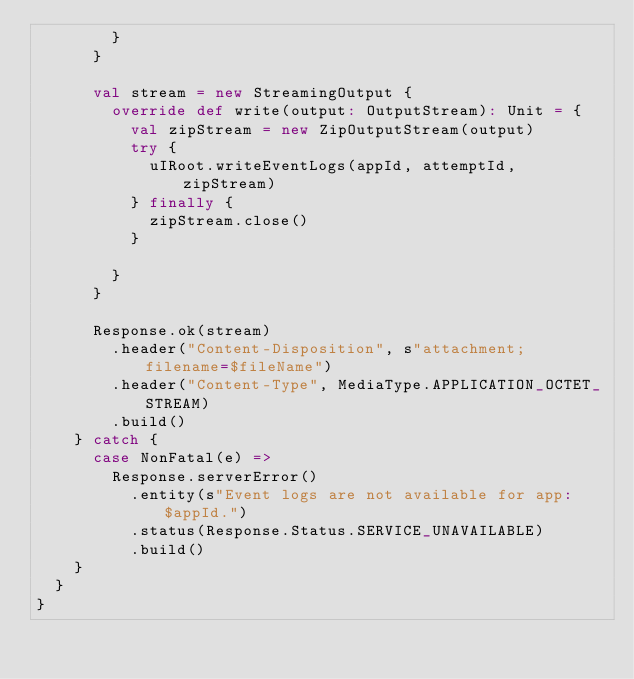Convert code to text. <code><loc_0><loc_0><loc_500><loc_500><_Scala_>        }
      }

      val stream = new StreamingOutput {
        override def write(output: OutputStream): Unit = {
          val zipStream = new ZipOutputStream(output)
          try {
            uIRoot.writeEventLogs(appId, attemptId, zipStream)
          } finally {
            zipStream.close()
          }

        }
      }

      Response.ok(stream)
        .header("Content-Disposition", s"attachment; filename=$fileName")
        .header("Content-Type", MediaType.APPLICATION_OCTET_STREAM)
        .build()
    } catch {
      case NonFatal(e) =>
        Response.serverError()
          .entity(s"Event logs are not available for app: $appId.")
          .status(Response.Status.SERVICE_UNAVAILABLE)
          .build()
    }
  }
}
</code> 